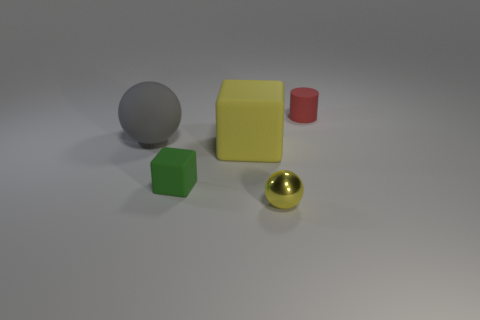Add 4 cyan cylinders. How many objects exist? 9 Subtract all cylinders. How many objects are left? 4 Add 1 purple blocks. How many purple blocks exist? 1 Subtract 0 blue cubes. How many objects are left? 5 Subtract all large matte objects. Subtract all tiny cylinders. How many objects are left? 2 Add 4 small red objects. How many small red objects are left? 5 